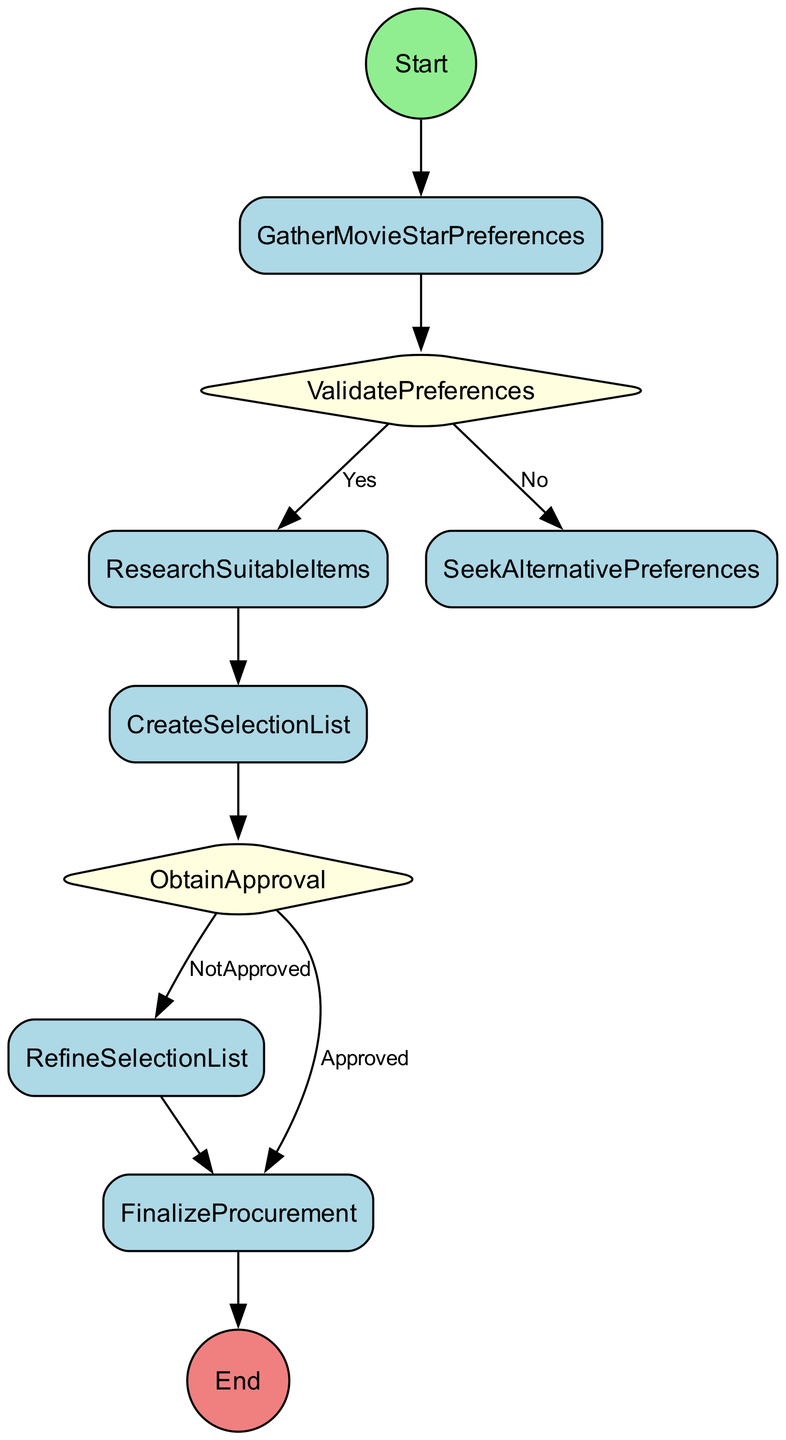What is the first action in the selection process? The diagram indicates that the first action is "GatherMovieStarPreferences," which is the initial step in the process.
Answer: GatherMovieStarPreferences What follows after the preferences are validated as aligning with current trends? According to the diagram, if the preferences are validated as aligning with current trends (Yes), the next action is "ResearchSuitableItems."
Answer: ResearchSuitableItems How many decision points are in the diagram? By examining the diagram, it can be seen that there are two decision points: "ValidatePreferences" and "ObtainApproval." Therefore, the total is two decision points.
Answer: 2 What happens if the selected items are not approved by the movie star? The diagram shows that if the items are not approved (NotApproved) at the "ObtainApproval" decision point, the next action is "RefineSelectionList."
Answer: RefineSelectionList What is the final action in the selection process? The diagram indicates that the last action before the process ends is "FinalizeProcurement," which concludes the selection process.
Answer: FinalizeProcurement What is the endpoint of this activity diagram? The endpoint of the diagram is marked as "CompleteSelectionProcess," indicating the conclusion of the process.
Answer: CompleteSelectionProcess What condition leads to seeking alternative preferences? The diagram specifies that if the preferences are not aligned with current trends (No) during "ValidatePreferences," this leads to "SeekAlternativePreferences."
Answer: SeekAlternativePreferences How many total actions are there in the diagram? Counting the distinct actions in the diagram, there are five actions: "GatherMovieStarPreferences," "ResearchSuitableItems," "CreateSelectionList," "RefineSelectionList," and "FinalizeProcurement."
Answer: 5 What is the condition that allows moving from "ObtainApproval" to "FinalizeProcurement"? If the selected items are "Approved" at the "ObtainApproval" decision point, it allows moving on to "FinalizeProcurement."
Answer: Approved 